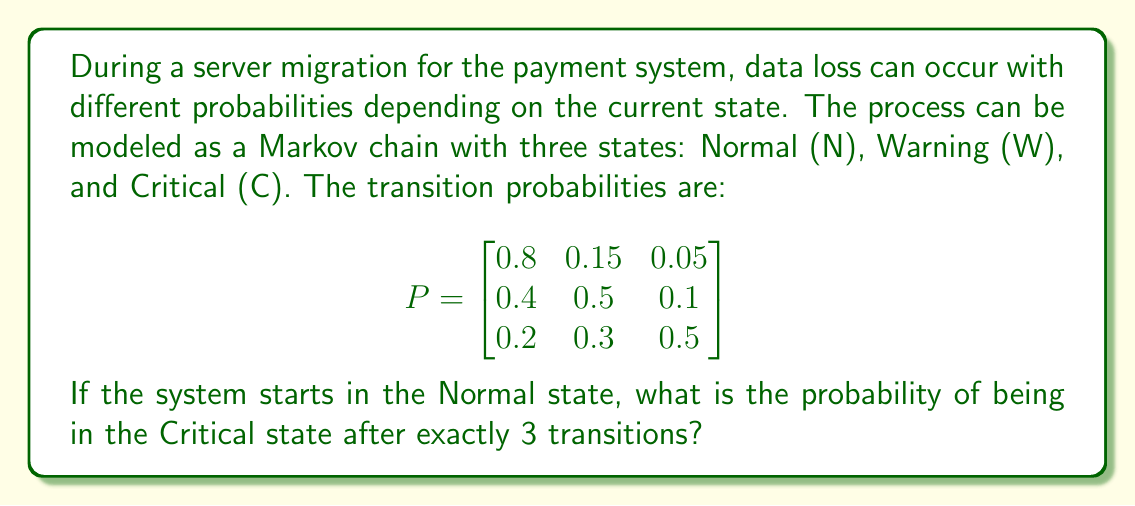Solve this math problem. To solve this problem, we need to use the Markov chain transition matrix and raise it to the power of 3. This will give us the probabilities of being in each state after exactly 3 transitions.

Step 1: Identify the initial state vector.
Since we start in the Normal state, our initial state vector is:
$$ v_0 = \begin{bmatrix} 1 & 0 & 0 \end{bmatrix} $$

Step 2: Calculate $P^3$ (the transition matrix raised to the power of 3).
$$ P^3 = P \times P \times P $$

We can use matrix multiplication to compute this:

$$ P^3 = \begin{bmatrix}
0.592 & 0.2775 & 0.1305 \\
0.544 & 0.3105 & 0.1455 \\
0.488 & 0.3270 & 0.1850
\end{bmatrix} $$

Step 3: Multiply the initial state vector by $P^3$.
$$ v_3 = v_0 \times P^3 = \begin{bmatrix} 1 & 0 & 0 \end{bmatrix} \times \begin{bmatrix}
0.592 & 0.2775 & 0.1305 \\
0.544 & 0.3105 & 0.1455 \\
0.488 & 0.3270 & 0.1850
\end{bmatrix} $$

$$ v_3 = \begin{bmatrix} 0.592 & 0.2775 & 0.1305 \end{bmatrix} $$

Step 4: The probability of being in the Critical state (the third element of $v_3$) is 0.1305 or 13.05%.
Answer: 0.1305 